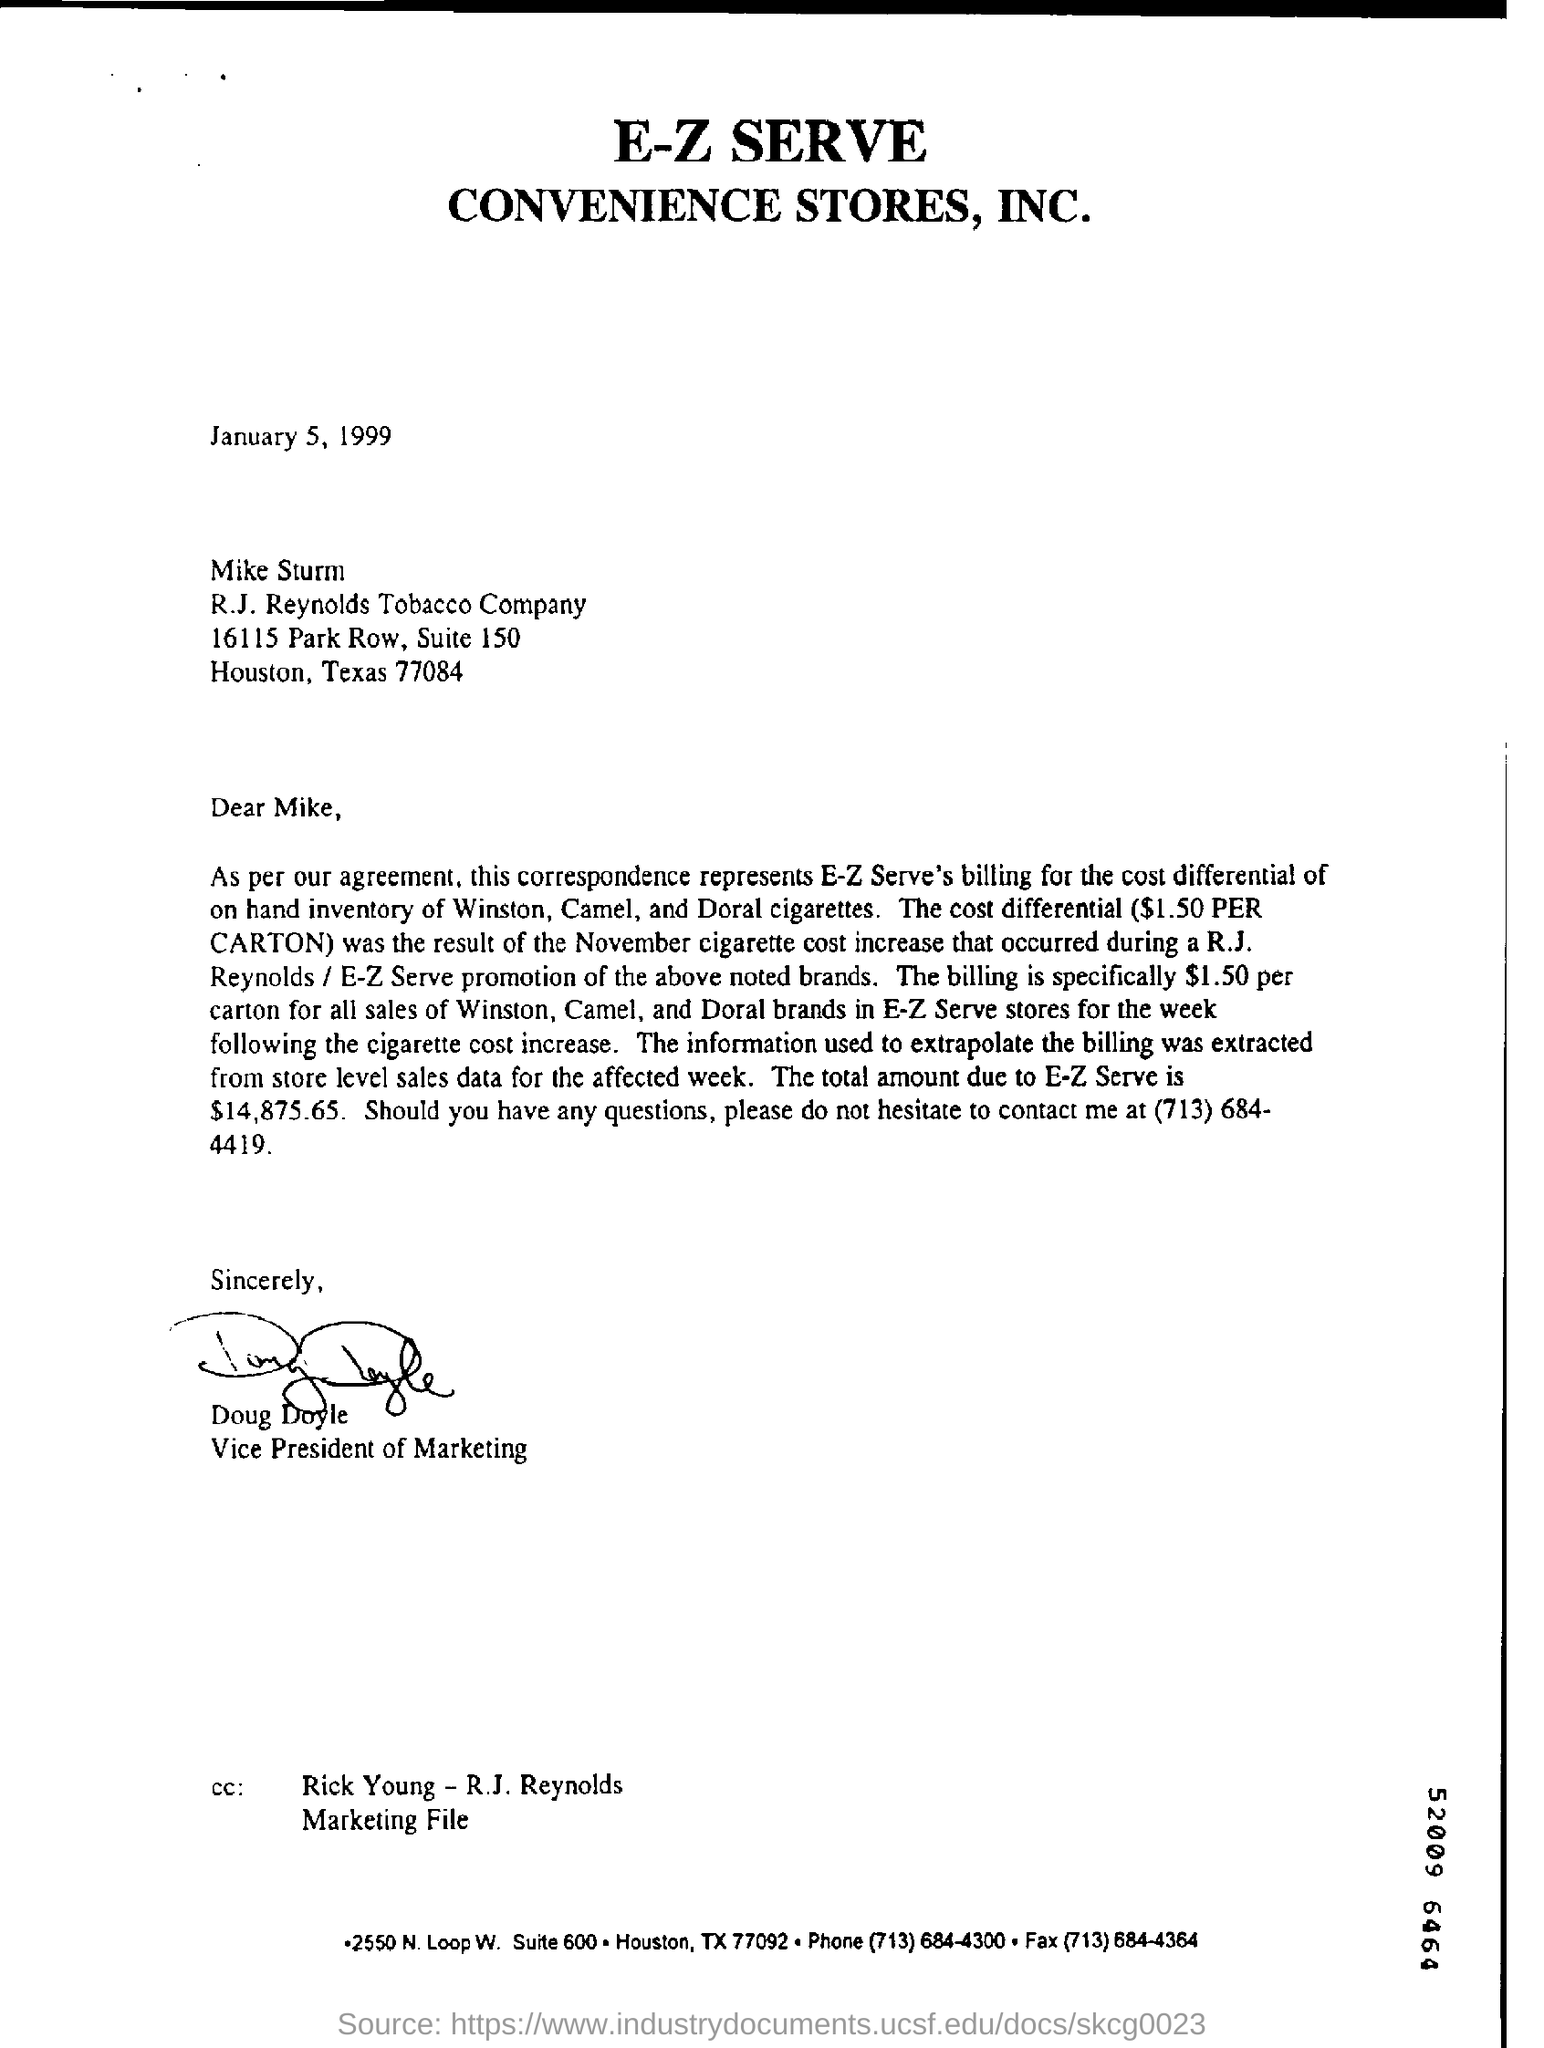What is the date of this letter?
Your response must be concise. January 5, 1999. Who is the addressee of this letter?
Provide a short and direct response. Mike. Who has signed the letter?
Offer a very short reply. Doug Doyle. What is the designation of Doug Doyle?
Your answer should be very brief. Vice President of Marketing. What is the total amount due to E-Z Serve?
Your response must be concise. $14,875.65. 